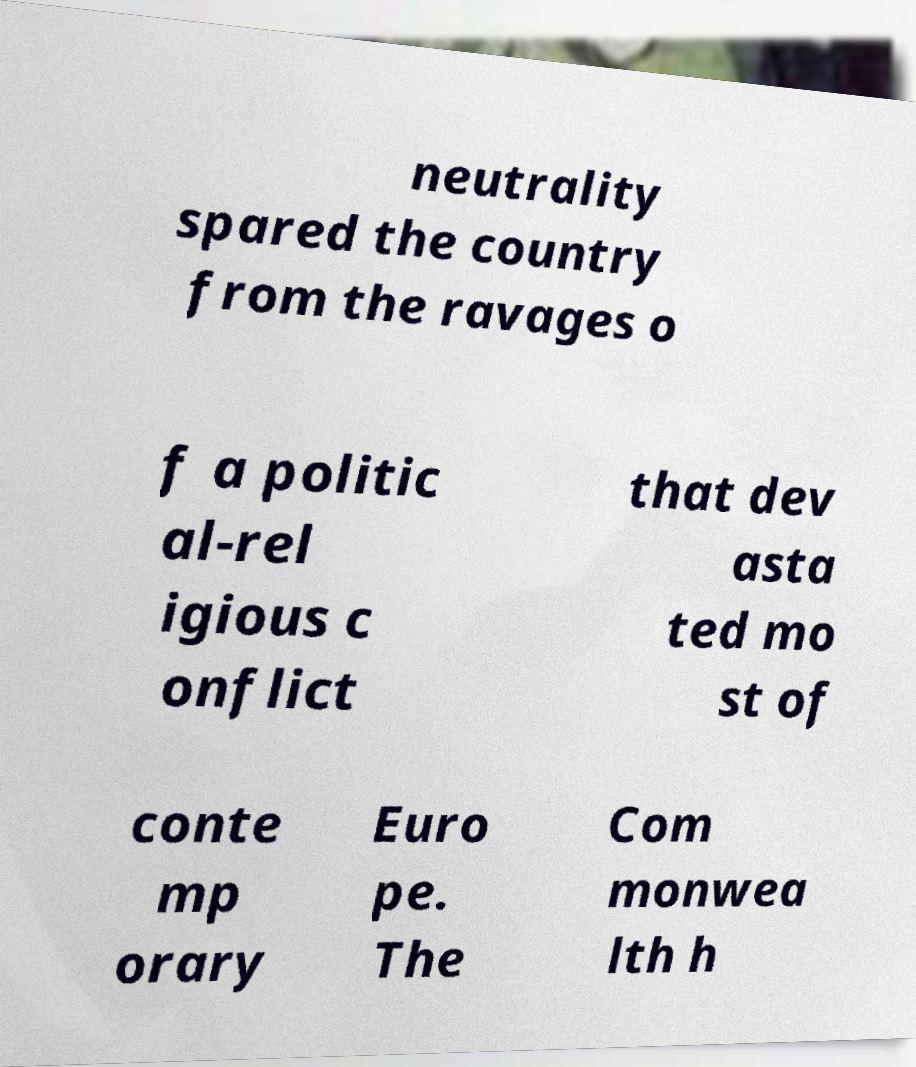There's text embedded in this image that I need extracted. Can you transcribe it verbatim? neutrality spared the country from the ravages o f a politic al-rel igious c onflict that dev asta ted mo st of conte mp orary Euro pe. The Com monwea lth h 